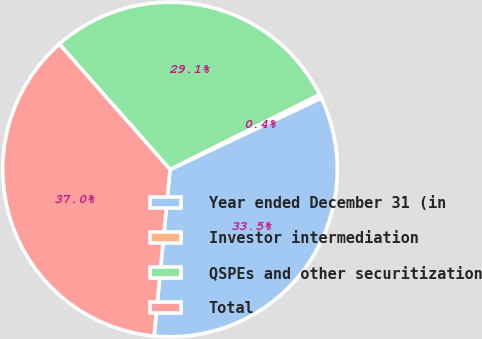Convert chart to OTSL. <chart><loc_0><loc_0><loc_500><loc_500><pie_chart><fcel>Year ended December 31 (in<fcel>Investor intermediation<fcel>QSPEs and other securitization<fcel>Total<nl><fcel>33.55%<fcel>0.37%<fcel>29.1%<fcel>36.98%<nl></chart> 